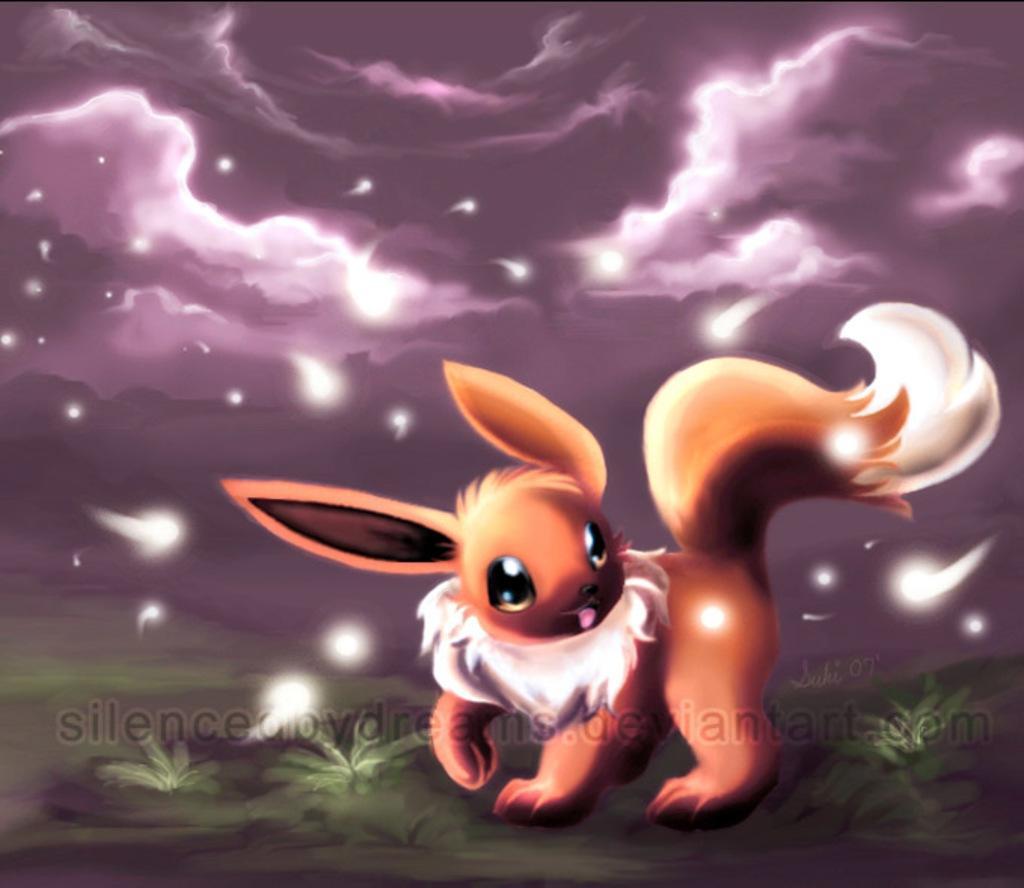Describe this image in one or two sentences. This looks like an animated image. This is an animal. Here is the grass. These are the clouds in the sky. I think these are the stars. This is the watermark on the image. 